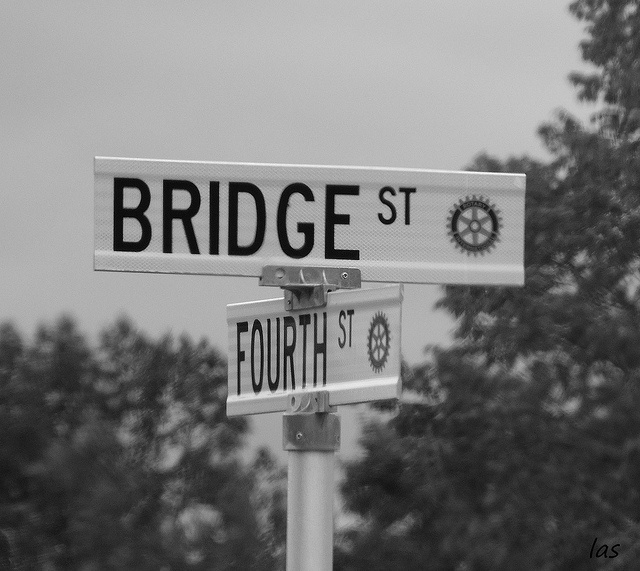Describe the objects in this image and their specific colors. I can see various objects in this image with different colors. 